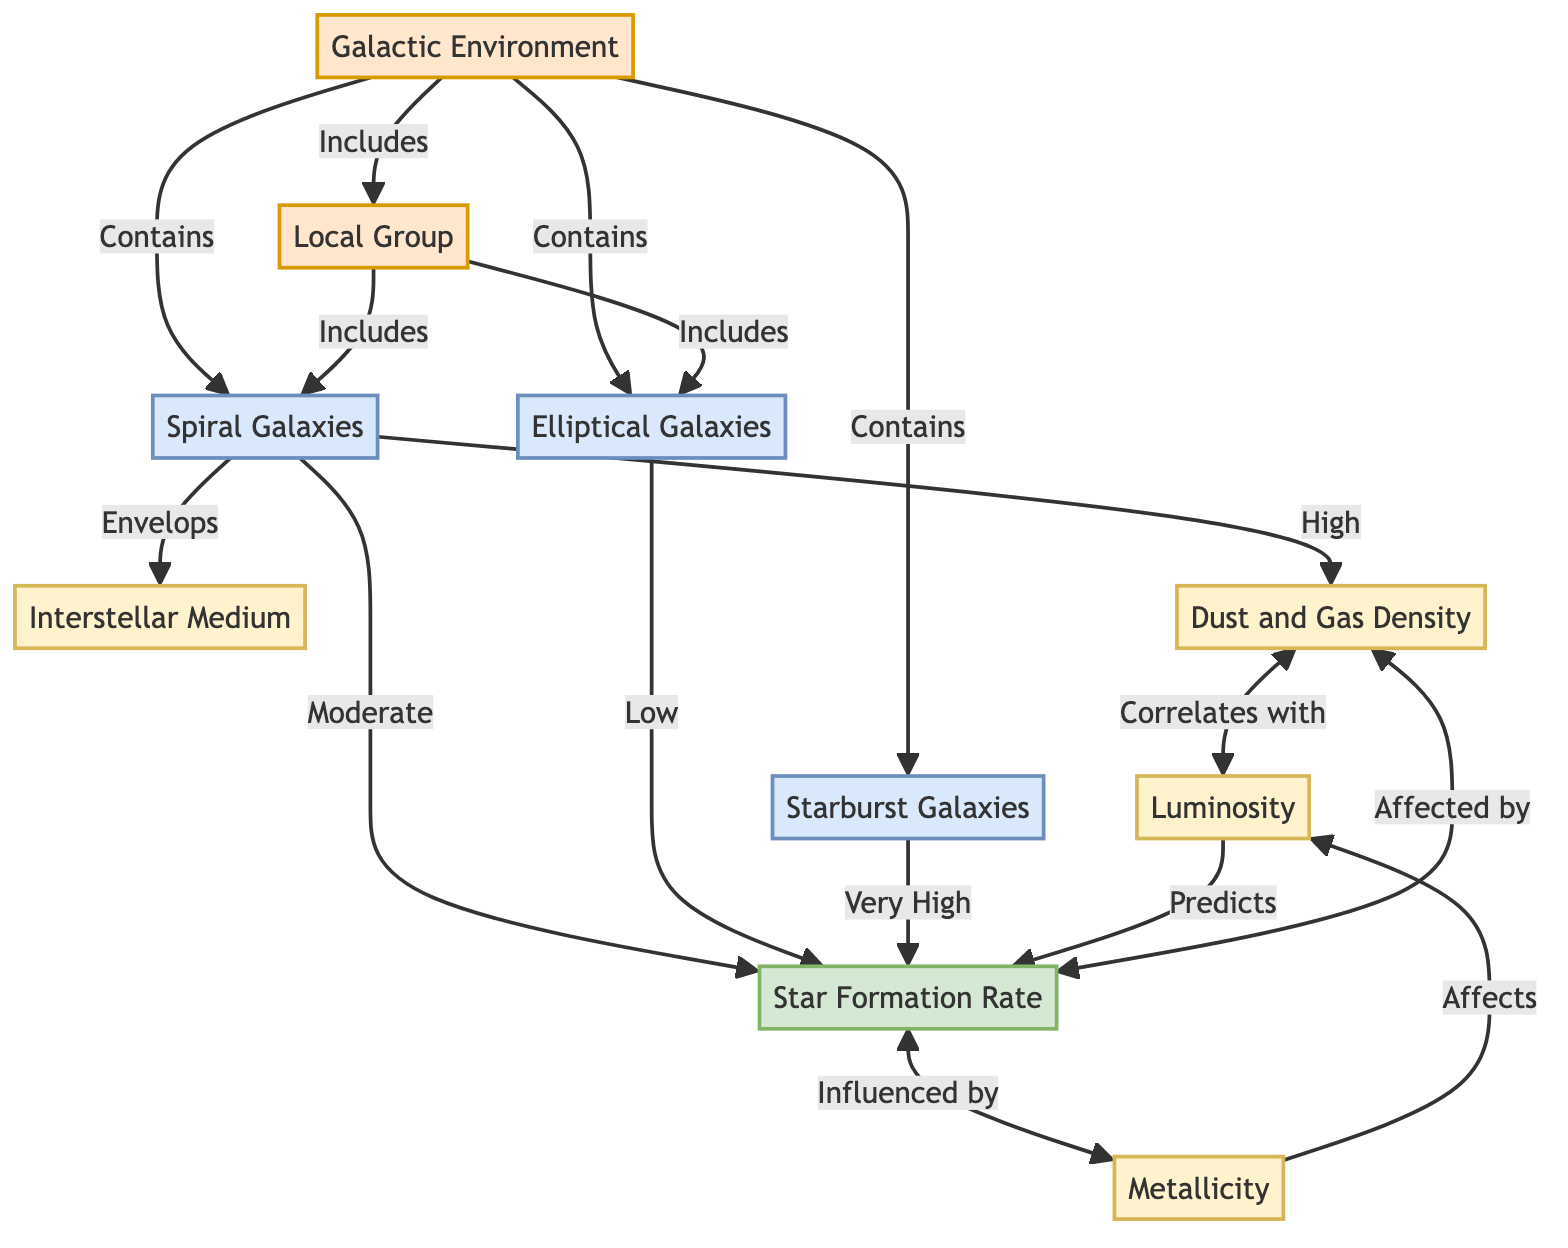What are the three types of galaxies included in the Galactic Environment? The diagram shows three specific types of galaxies under the Galactic Environment node: Spiral Galaxies, Elliptical Galaxies, and Starburst Galaxies. These are explicitly mentioned as being part of the relationships stemming from the Galactic Environment.
Answer: Spiral Galaxies, Elliptical Galaxies, Starburst Galaxies Which property is said to correlate with Dust and Gas Density? According to the diagram, Dust and Gas Density is correlated with Luminosity, as indicated by the directed link between these two nodes.
Answer: Luminosity What is the Star Formation Rate in Interstellar Medium according to the diagram? The diagram suggests that the Star Formation Rate is moderate in Spiral Galaxies since Interstellar Medium envelops Spiral Galaxies, which influences the overall Star Formation Rate in that context.
Answer: Moderate Which environment encapsulates both Spiral and Elliptical Galaxies? The diagram shows that both Spiral and Elliptical Galaxies are included within the Local Group environment as represented by the directional arrow leading to them.
Answer: Local Group How many nodes represent properties in the diagram? The diagram displays a total of four nodes that represent properties: Interstellar Medium, Dust and Gas Density, Luminosity, and Metallicity. By counting these specific nodes, the answer is determined.
Answer: Four What is the influence of Metallicity on Luminosity? The diagram indicates that Metallicity affects Luminosity, as shown by the directed arrow from Metallicity to Luminosity, which implies that changes in Metallicity will have an effect on the Luminosity values.
Answer: Affects Which type of galaxy is associated with a very high Star Formation Rate? The diagram explicitly states that Starburst Galaxies are associated with a very high Star Formation Rate, as stated in the relationship indicated.
Answer: Starburst Galaxies What are the two environmental categories mentioned in the diagram? The diagram identifies two key environmental categories: Galactic Environment and Local Group, which serve as overarching nodes for the galaxies and their conditions.
Answer: Galactic Environment, Local Group 